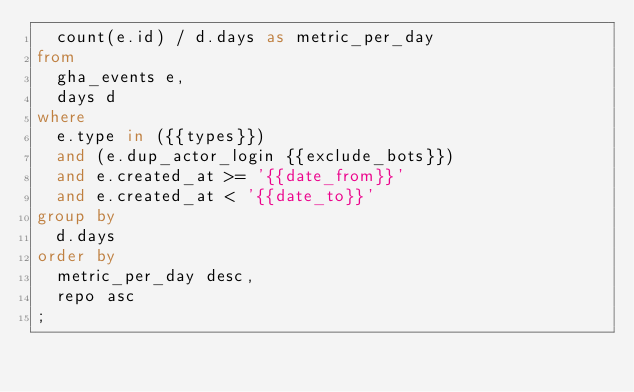<code> <loc_0><loc_0><loc_500><loc_500><_SQL_>  count(e.id) / d.days as metric_per_day
from
  gha_events e,
  days d
where
  e.type in ({{types}})
  and (e.dup_actor_login {{exclude_bots}})
  and e.created_at >= '{{date_from}}'
  and e.created_at < '{{date_to}}'
group by
  d.days
order by
  metric_per_day desc,
  repo asc
;
</code> 